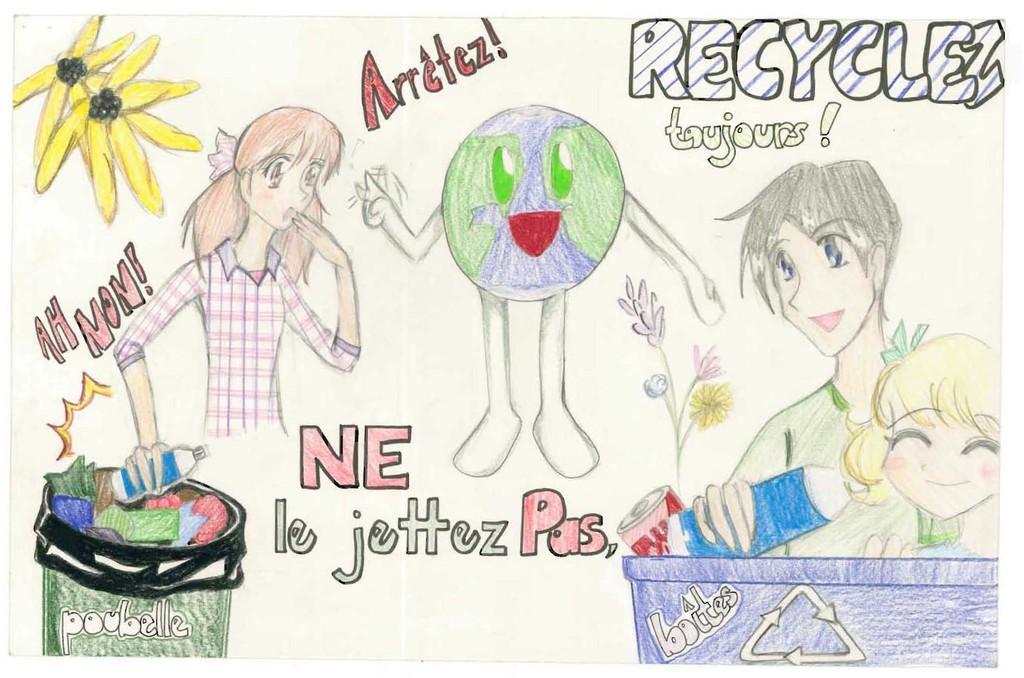Please provide a concise description of this image. In this image we can see drawing of some people holding bottles , some flowers and a trash bin. 